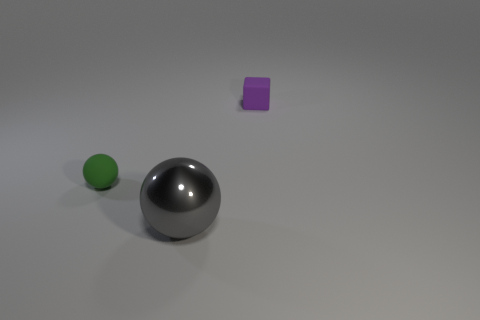Add 2 tiny matte blocks. How many objects exist? 5 Subtract all spheres. How many objects are left? 1 Subtract 0 cyan blocks. How many objects are left? 3 Subtract 1 blocks. How many blocks are left? 0 Subtract all yellow spheres. Subtract all green cylinders. How many spheres are left? 2 Subtract all small purple objects. Subtract all small green matte balls. How many objects are left? 1 Add 2 large gray spheres. How many large gray spheres are left? 3 Add 1 gray things. How many gray things exist? 2 